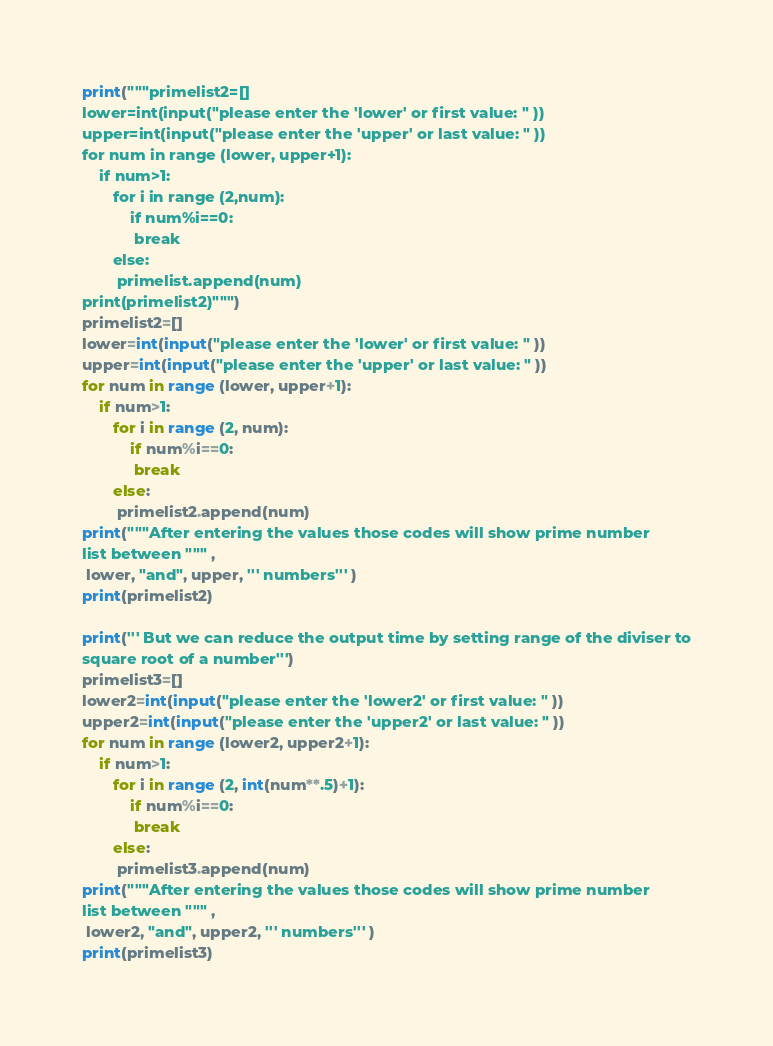<code> <loc_0><loc_0><loc_500><loc_500><_Python_>
print("""primelist2=[]
lower=int(input("please enter the 'lower' or first value: " ))
upper=int(input("please enter the 'upper' or last value: " ))
for num in range (lower, upper+1):
    if num>1:
       for i in range (2,num):
           if num%i==0:
            break
       else:
        primelist.append(num)
print(primelist2)""")
primelist2=[]
lower=int(input("please enter the 'lower' or first value: " ))
upper=int(input("please enter the 'upper' or last value: " ))
for num in range (lower, upper+1):
    if num>1:
       for i in range (2, num):
           if num%i==0:
            break
       else:
        primelist2.append(num)
print("""After entering the values those codes will show prime number
list between """ ,
 lower, "and", upper, ''' numbers''' )
print(primelist2)

print(''' But we can reduce the output time by setting range of the diviser to
square root of a number''')
primelist3=[]
lower2=int(input("please enter the 'lower2' or first value: " ))
upper2=int(input("please enter the 'upper2' or last value: " ))
for num in range (lower2, upper2+1):
    if num>1:
       for i in range (2, int(num**.5)+1):
           if num%i==0:
            break
       else:
        primelist3.append(num)
print("""After entering the values those codes will show prime number
list between """ ,
 lower2, "and", upper2, ''' numbers''' )
print(primelist3)</code> 